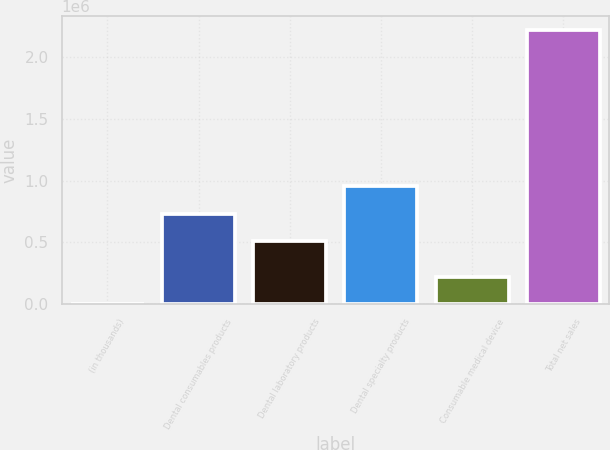<chart> <loc_0><loc_0><loc_500><loc_500><bar_chart><fcel>(in thousands)<fcel>Dental consumables products<fcel>Dental laboratory products<fcel>Dental specialty products<fcel>Consumable medical device<fcel>Total net sales<nl><fcel>2010<fcel>732961<fcel>511061<fcel>954862<fcel>223910<fcel>2.22101e+06<nl></chart> 